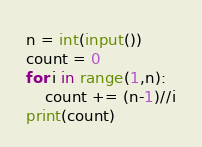<code> <loc_0><loc_0><loc_500><loc_500><_Python_>n = int(input())
count = 0
for i in range(1,n):
    count += (n-1)//i
print(count)
</code> 